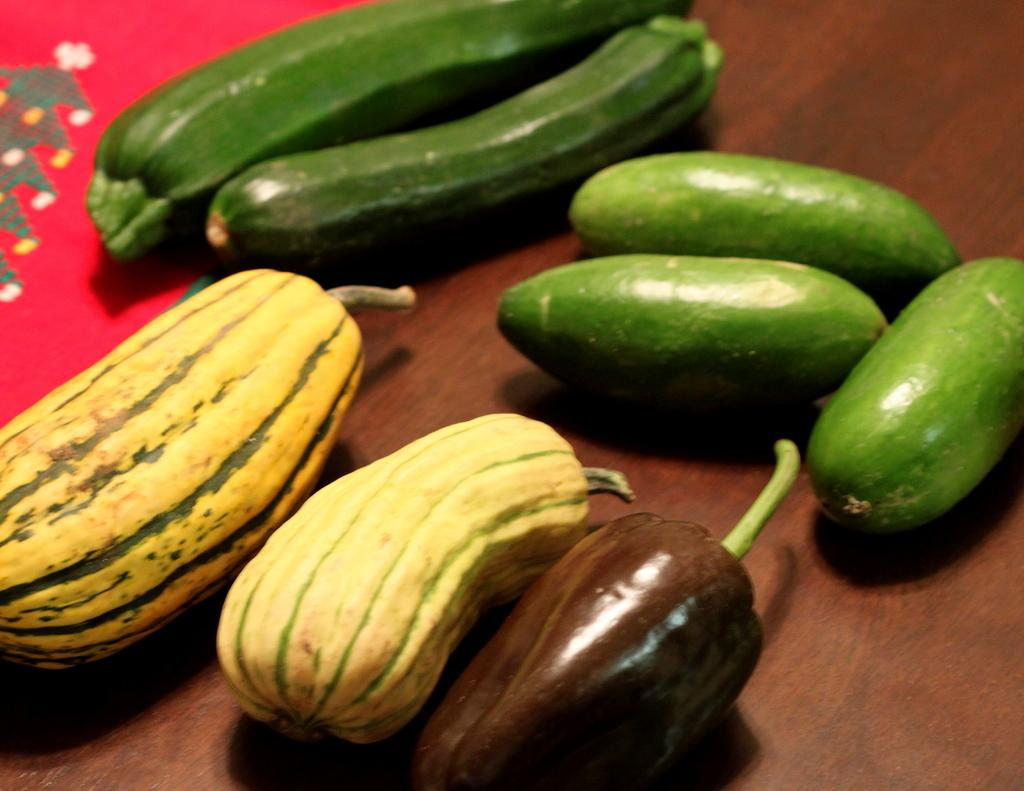What type of food can be seen in the image? There are vegetables in the image. What colors are present in the vegetables? The vegetables have green, yellow, and brown colors. Where are the vegetables placed in the image? The vegetables are kept on a table. Can you describe the setting of the image? The image may have been taken in a room. What type of beam can be seen supporting the vegetables in the image? There is no beam present in the image; the vegetables are simply placed on a table. 